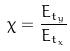<formula> <loc_0><loc_0><loc_500><loc_500>\chi = \frac { E _ { t _ { y } } } { E _ { t _ { x } } }</formula> 